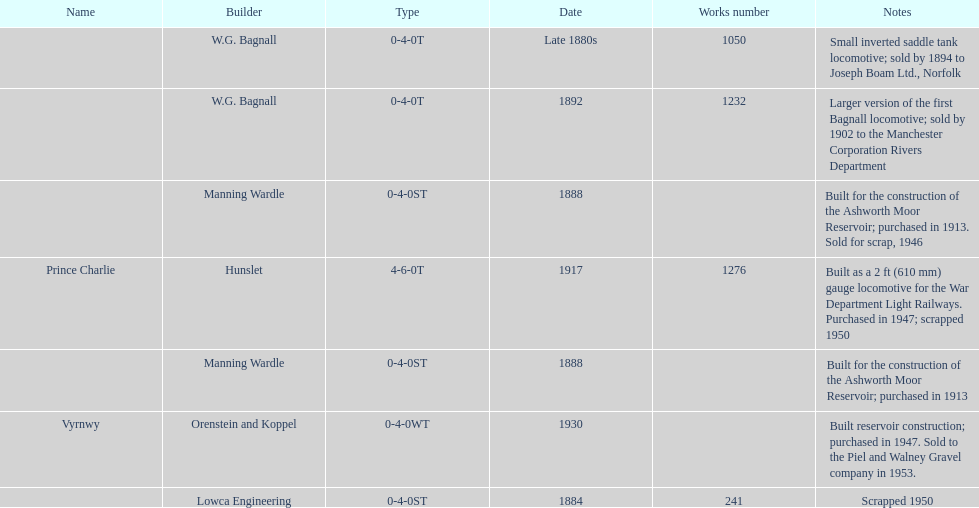How many locomotives were built for the construction of the ashworth moor reservoir? 2. 